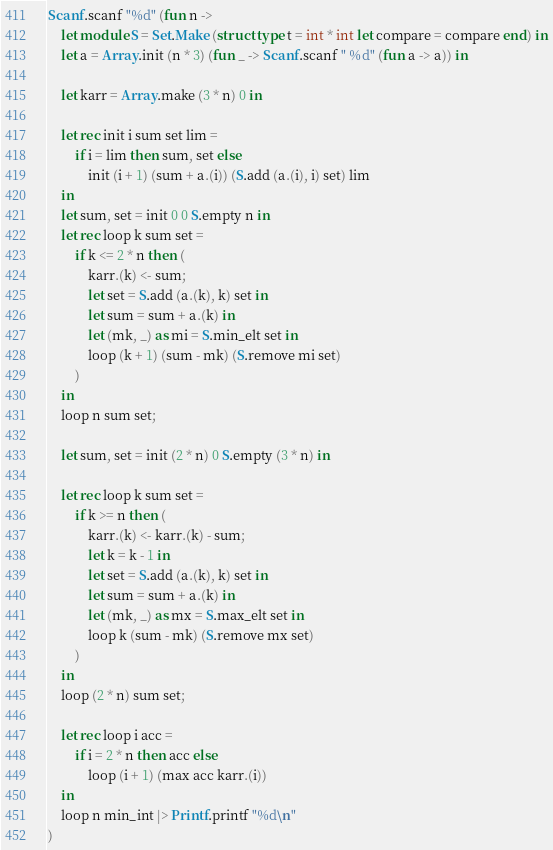Convert code to text. <code><loc_0><loc_0><loc_500><loc_500><_OCaml_>Scanf.scanf "%d" (fun n ->
    let module S = Set.Make (struct type t = int * int let compare = compare end) in
    let a = Array.init (n * 3) (fun _ -> Scanf.scanf " %d" (fun a -> a)) in

    let karr = Array.make (3 * n) 0 in

    let rec init i sum set lim =
        if i = lim then sum, set else
            init (i + 1) (sum + a.(i)) (S.add (a.(i), i) set) lim
    in
    let sum, set = init 0 0 S.empty n in
    let rec loop k sum set =
        if k <= 2 * n then (
            karr.(k) <- sum;
            let set = S.add (a.(k), k) set in
            let sum = sum + a.(k) in
            let (mk, _) as mi = S.min_elt set in
            loop (k + 1) (sum - mk) (S.remove mi set)
        )
    in
    loop n sum set;

    let sum, set = init (2 * n) 0 S.empty (3 * n) in

    let rec loop k sum set =
        if k >= n then (
            karr.(k) <- karr.(k) - sum;
            let k = k - 1 in
            let set = S.add (a.(k), k) set in
            let sum = sum + a.(k) in
            let (mk, _) as mx = S.max_elt set in
            loop k (sum - mk) (S.remove mx set)
        )
    in
    loop (2 * n) sum set;

    let rec loop i acc =
        if i = 2 * n then acc else
            loop (i + 1) (max acc karr.(i))
    in
    loop n min_int |> Printf.printf "%d\n"
)
</code> 